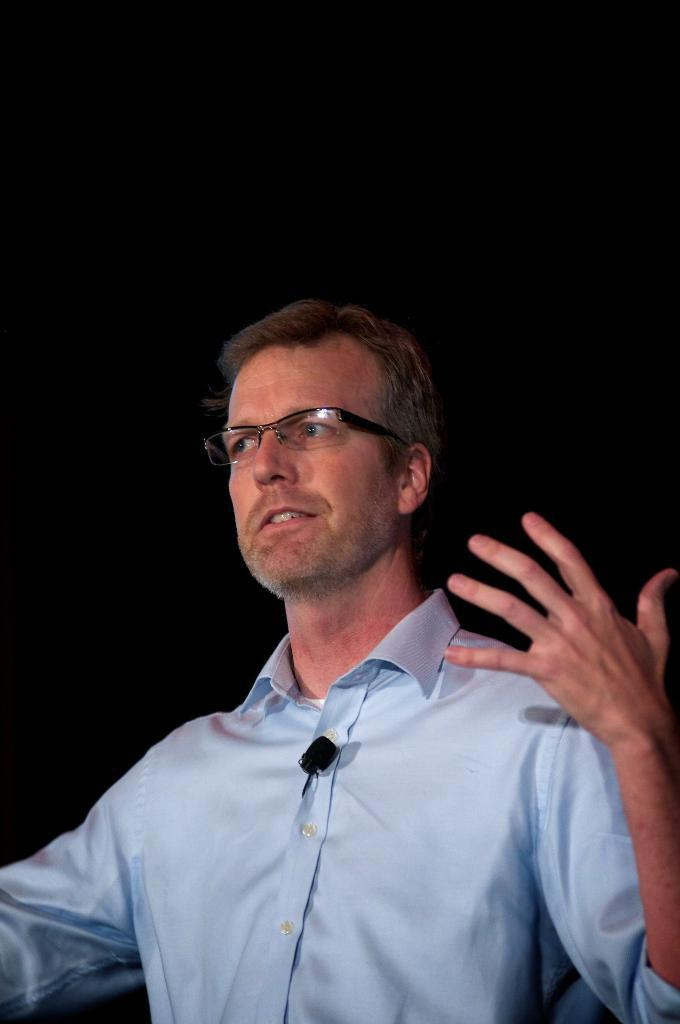What is the main subject of the image? The main subject of the image is a man. Where is the man located in the image? The man is standing in the center of the image. What accessory is the man wearing in the image? The man is wearing glasses in the image. What type of mask is the man wearing in the image? There is no mask present in the image; the man is wearing glasses. How does the man's appearance compare to that of a farmer in the image? There is no farmer present in the image, so it is not possible to make a comparison. 